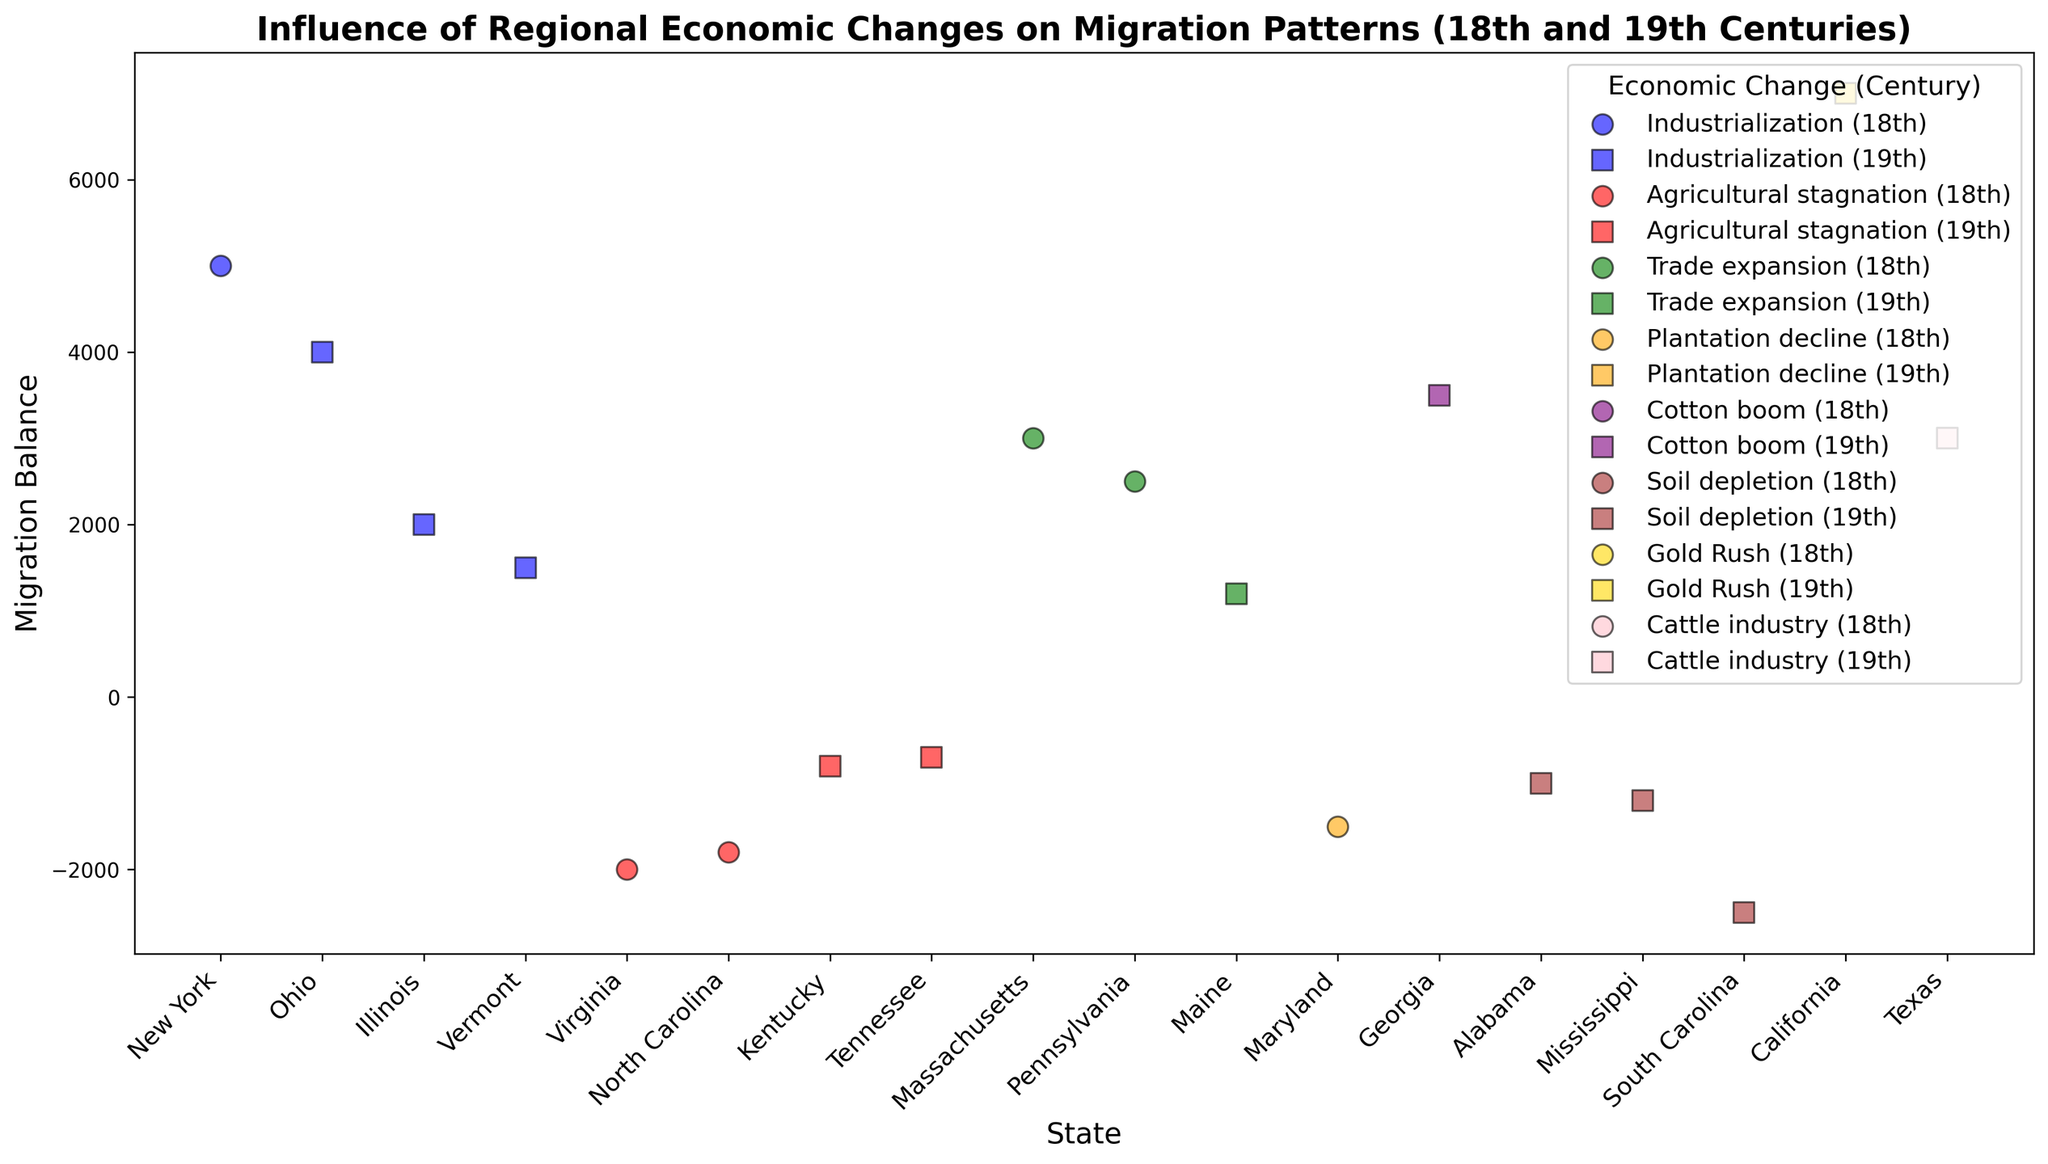What state's migration balance was most impacted by the Gold Rush? The Gold Rush is represented by the color gold. By identifying the gold-colored marker with the highest migration balance, we can see that California's migration balance is 7000.
Answer: California Which century saw the greatest migration balance for industrialization? To determine this, we need to look at the blue markers (industrialization) in both centuries. Comparing the 18th-century markers and 19th-century markers, we see that the highest migration balance for industrialization in the 18th century is 5000 (New York) and in the 19th century is 4000 (Ohio). Therefore, the greatest migration balance for industrialization is in the 18th century.
Answer: 18th century How many states had a negative migration balance due to agricultural stagnation? Agricultural stagnation is represented by the color red. By counting the red markers below the zero line, we find there are four states with negative migration balances: Virginia, North Carolina, Kentucky, and Tennessee.
Answer: 4 Which economic change led to the highest positive migration balance in the 19th century? Colors can be used to identify the different economic changes. For the 19th century, the marker shapes are squares. Comparing the markers, the highest positive migration balance is 7000 for California, represented by the color gold which corresponds to the Gold Rush.
Answer: Gold Rush What is the difference in migration balance between the state with the lowest and the highest balance in the 18th century? First, identify the lowest and highest migration balances in the 18th century, marked by circles. The highest is New York (5000) and the lowest is Virginia (-2000). The difference is calculated as 5000 - (-2000) = 7000.
Answer: 7000 Which state had the highest negative migration balance and what was the associated economic change? To find this, look for the marker furthest below the zero line. The state with the highest negative balance is South Carolina with -2500, which is represented by the color brown, indicating soil depletion.
Answer: South Carolina, Soil depletion How did trade expansion impact migration balances during the 18th and 19th centuries? Identifying the markers colored green (trade expansion) and noting their respective shapes reveals the migration balances. In the 18th century, Massachusetts (3000) and Pennsylvania (2500) saw positive balances. In the 19th century, Maine (1200) also saw a positive balance. Overall, trade expansion led to positive migration balances in both centuries.
Answer: Positive in both centuries What is the average migration balance for states affected by soil depletion in the 19th century? Soil depletion is represented by the color brown. In the 19th century, there are three states: Alabama (-1000), Mississippi (-1200), and South Carolina (-2500). The average is calculated as (-1000 + -1200 + -2500) / 3 = -4700 / 3 ≈ -1567.
Answer: -1567 Compare the migration balances of Ohio and Illinois during the 19th century under industrialization. Both states (blue markers shaped as squares) in the 19th century include Ohio (4000) and Illinois (2000). Ohio has a higher migration balance compared to Illinois.
Answer: Ohio has a higher balance (4000 vs. 2000) What pattern, if any, can you observe regarding migration balances and agricultural stagnation? Focusing on the red markers reveals that agricultural stagnation consistently results in negative migration balances. This pattern is observed across several states in different centuries.
Answer: Negative balances 